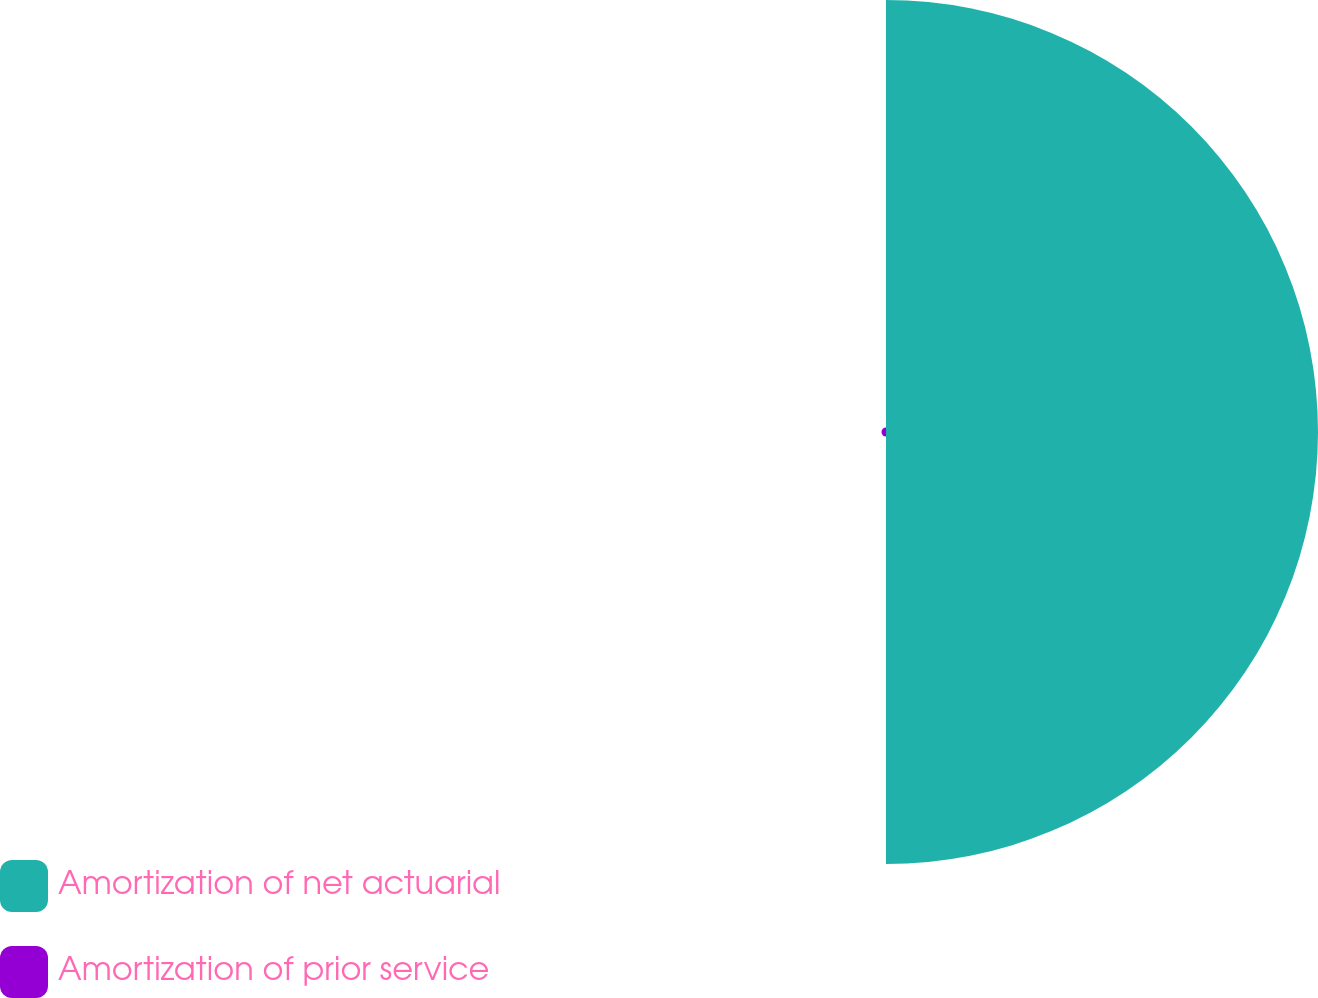Convert chart. <chart><loc_0><loc_0><loc_500><loc_500><pie_chart><fcel>Amortization of net actuarial<fcel>Amortization of prior service<nl><fcel>98.97%<fcel>1.03%<nl></chart> 